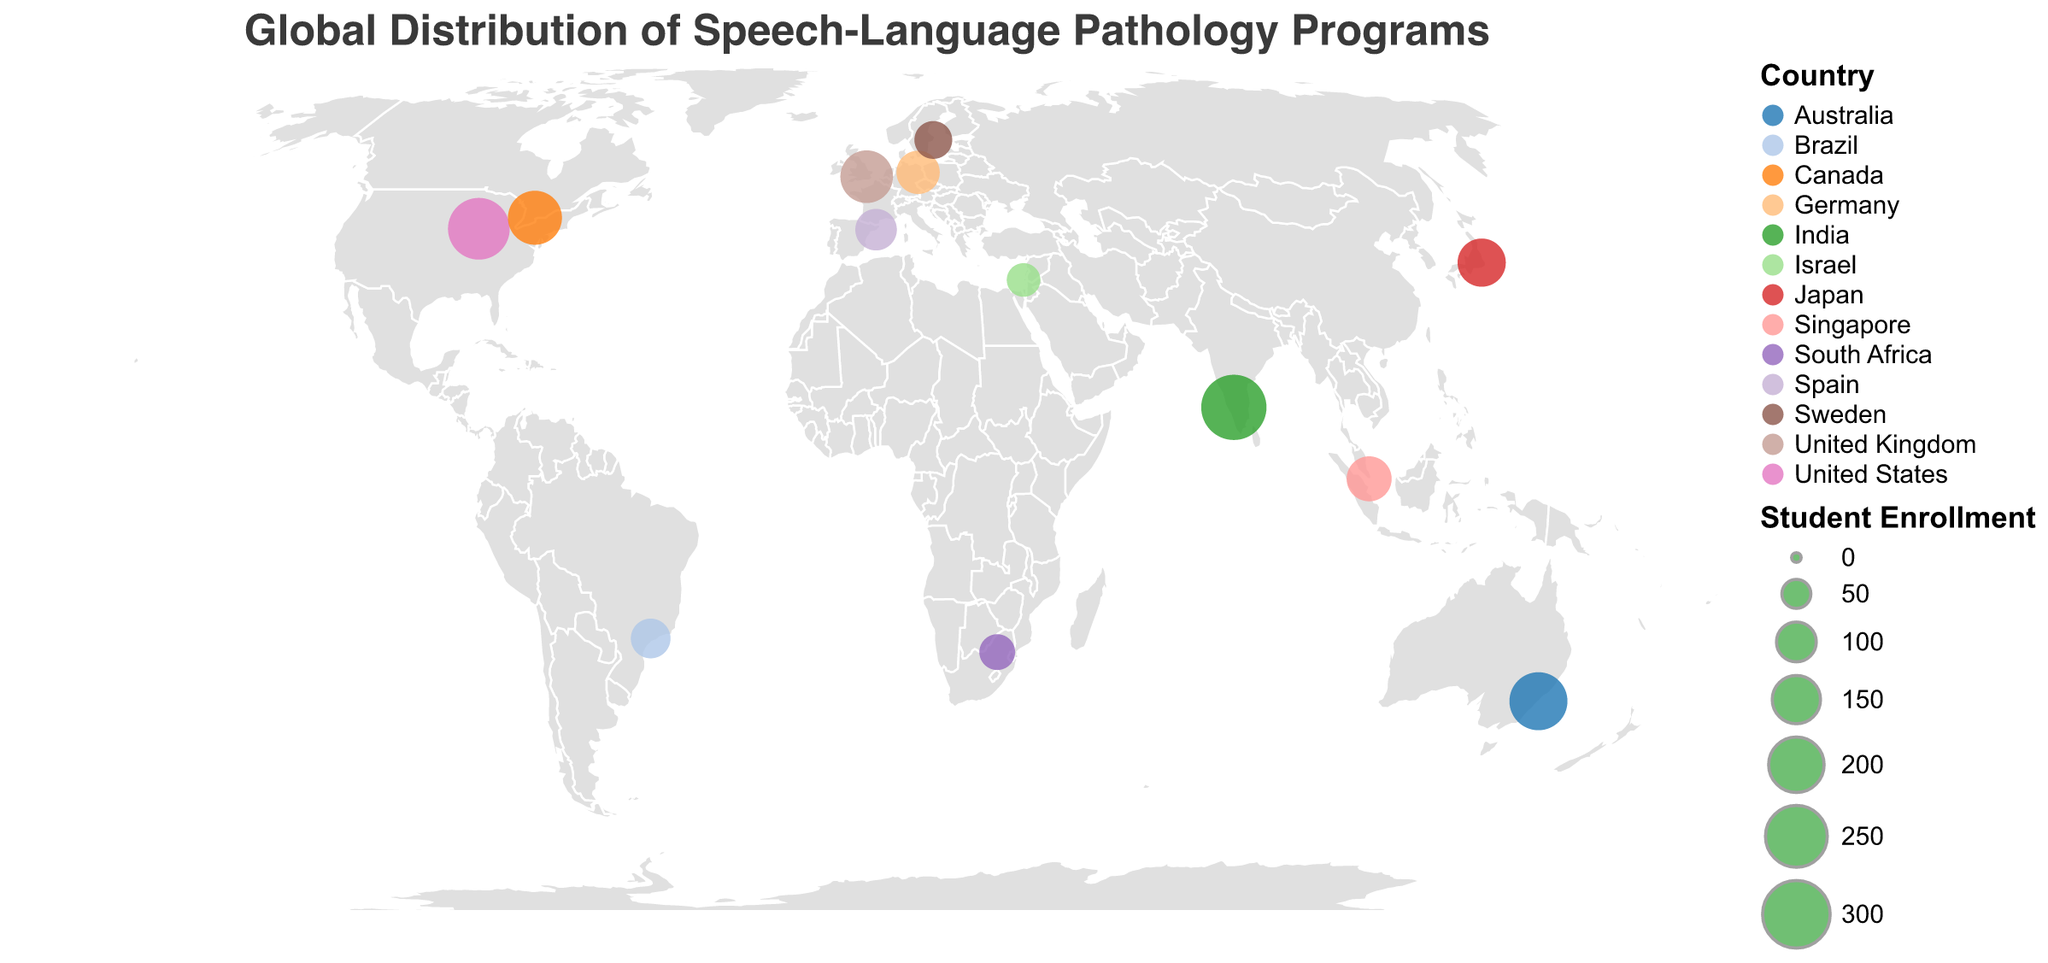What is the title of the figure? The title is usually located at the top of the figure. It reads "Global Distribution of Speech-Language Pathology Programs".
Answer: Global Distribution of Speech-Language Pathology Programs How many institutions are represented in the figure? Each institution is represented as a distinct circle on the map. Counting these circles gives the total number of institutions.
Answer: 13 Which country has the highest student enrollment for its speech-language pathology program? Looking at the sizes of the circles, find the largest circle and its corresponding tooltip information. The largest one is in India with 280 students.
Answer: India What is the total number of students enrolled in the programs across all institutions? Add up all the student enrollment numbers given in the tooltips or data labels for all institutions: 250 + 180 + 220 + 190 + 120 + 150 + 100 + 280 + 80 + 110 + 90 + 130 + 70.
Answer: 1970 Between the University of Sydney and the National University of Singapore, which has a higher student enrollment, and by how much? Compare the student enrollment figures for the two institutions. The University of Sydney has 220 students, and the National University of Singapore has 130 students. Subtract the smaller number from the larger one to find the difference: 220 - 130.
Answer: University of Sydney by 90 Which continent has the most institutions offering specialized programs for speech-language pathology? Observe the distribution of circles and their continents. Count the institutions per continent.
Answer: Europe What is the average student enrollment across all the institutions in the map? Sum all the student enrollments and divide by the number of institutions: (250 + 180 + 220 + 190 + 120 + 150 + 100 + 280 + 80 + 110 + 90 + 130 + 70) / 13.
Answer: 151.54 What color is used to represent institutions in Canada and Germany on the map? Find the circles located over Canada and Germany regions, then observe their colors.
Answer: Canada: Orange; Germany: Blue Which institution has the lowest student enrollment, and how many students are enrolled there? Look for the smallest circle on the map and check its tooltip for enrollment information. The University of Haifa in Israel has the smallest circle, indicating the smallest enrollment.
Answer: University of Haifa with 70 students What is the ratio of student enrollment between the largest institution and the smallest institution? Divide the student enrollment of the institution with the highest enrollment (All India Institute of Speech and Hearing, 280) by the enrollment of the smallest (University of Haifa, 70): 280 / 70.
Answer: 4:1 